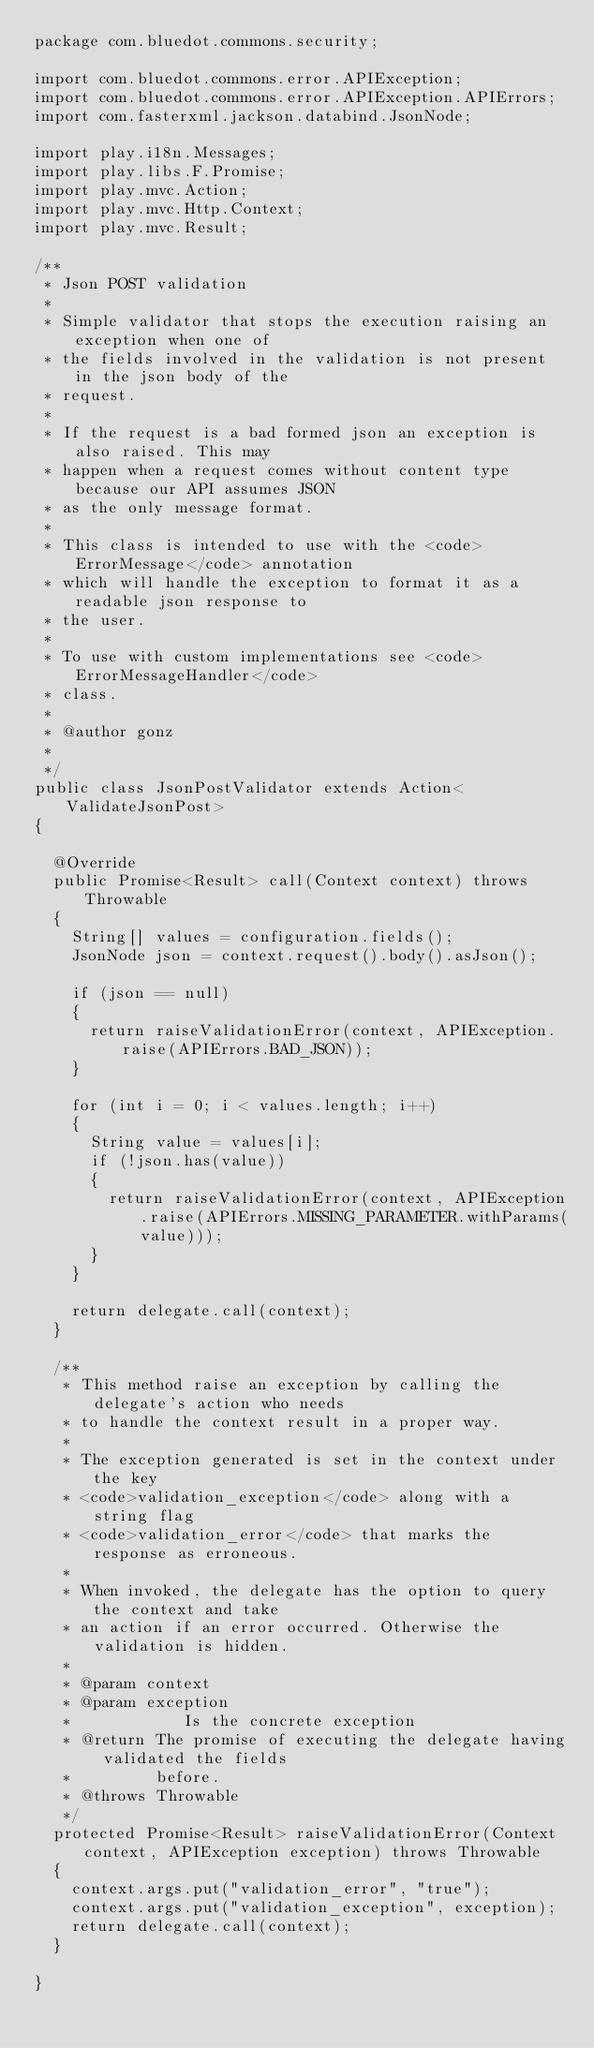Convert code to text. <code><loc_0><loc_0><loc_500><loc_500><_Java_>package com.bluedot.commons.security;

import com.bluedot.commons.error.APIException;
import com.bluedot.commons.error.APIException.APIErrors;
import com.fasterxml.jackson.databind.JsonNode;

import play.i18n.Messages;
import play.libs.F.Promise;
import play.mvc.Action;
import play.mvc.Http.Context;
import play.mvc.Result;

/**
 * Json POST validation
 * 
 * Simple validator that stops the execution raising an exception when one of
 * the fields involved in the validation is not present in the json body of the
 * request.
 * 
 * If the request is a bad formed json an exception is also raised. This may
 * happen when a request comes without content type because our API assumes JSON
 * as the only message format.
 * 
 * This class is intended to use with the <code>ErrorMessage</code> annotation
 * which will handle the exception to format it as a readable json response to
 * the user.
 * 
 * To use with custom implementations see <code>ErrorMessageHandler</code>
 * class.
 * 
 * @author gonz
 * 
 */
public class JsonPostValidator extends Action<ValidateJsonPost>
{

	@Override
	public Promise<Result> call(Context context) throws Throwable
	{
		String[] values = configuration.fields();
		JsonNode json = context.request().body().asJson();

		if (json == null)
		{
			return raiseValidationError(context, APIException.raise(APIErrors.BAD_JSON));
		}

		for (int i = 0; i < values.length; i++)
		{
			String value = values[i];
			if (!json.has(value))
			{
				return raiseValidationError(context, APIException.raise(APIErrors.MISSING_PARAMETER.withParams(value)));
			}
		}

		return delegate.call(context);
	}

	/**
	 * This method raise an exception by calling the delegate's action who needs
	 * to handle the context result in a proper way.
	 * 
	 * The exception generated is set in the context under the key
	 * <code>validation_exception</code> along with a string flag
	 * <code>validation_error</code> that marks the response as erroneous.
	 * 
	 * When invoked, the delegate has the option to query the context and take
	 * an action if an error occurred. Otherwise the validation is hidden.
	 * 
	 * @param context
	 * @param exception
	 *            Is the concrete exception
	 * @return The promise of executing the delegate having validated the fields
	 *         before.
	 * @throws Throwable
	 */
	protected Promise<Result> raiseValidationError(Context context, APIException exception) throws Throwable
	{
		context.args.put("validation_error", "true");
		context.args.put("validation_exception", exception);
		return delegate.call(context);
	}

}
</code> 